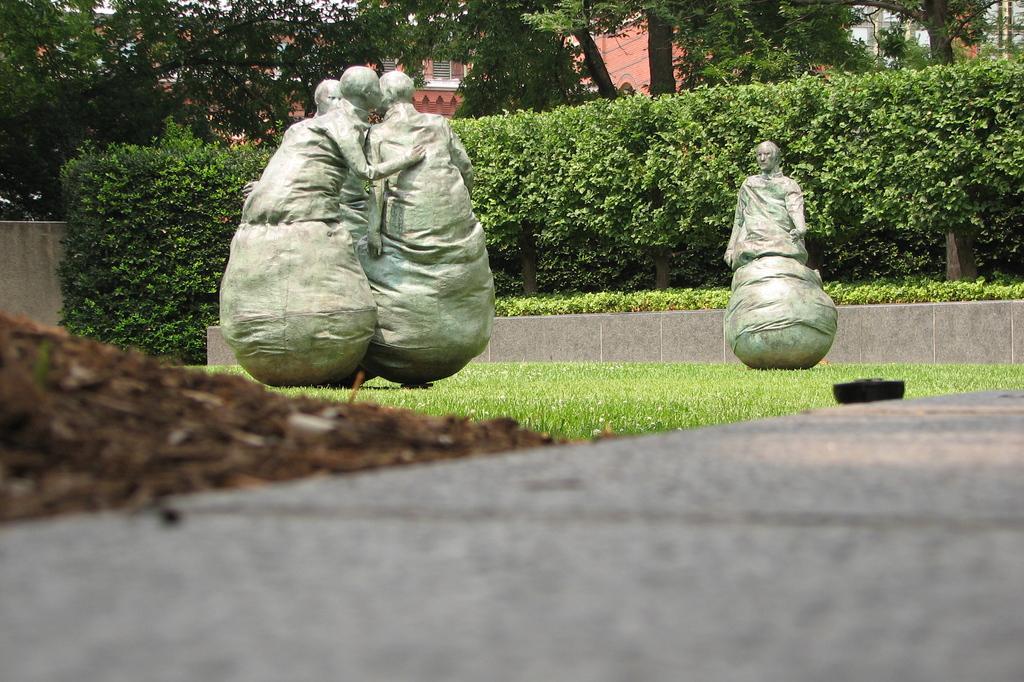Please provide a concise description of this image. In this picture in the center there is dry grass and there are statues. In the background there are plants, trees and buildings and in the front on the left side there is an object which is brown in colour. 